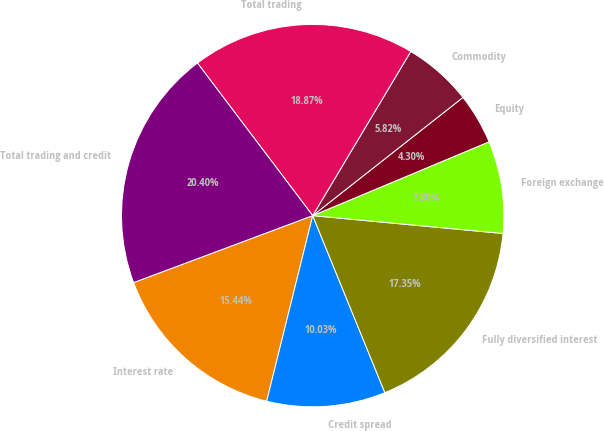Convert chart. <chart><loc_0><loc_0><loc_500><loc_500><pie_chart><fcel>Interest rate<fcel>Credit spread<fcel>Fully diversified interest<fcel>Foreign exchange<fcel>Equity<fcel>Commodity<fcel>Total trading<fcel>Total trading and credit<nl><fcel>15.44%<fcel>10.03%<fcel>17.35%<fcel>7.8%<fcel>4.3%<fcel>5.82%<fcel>18.87%<fcel>20.4%<nl></chart> 